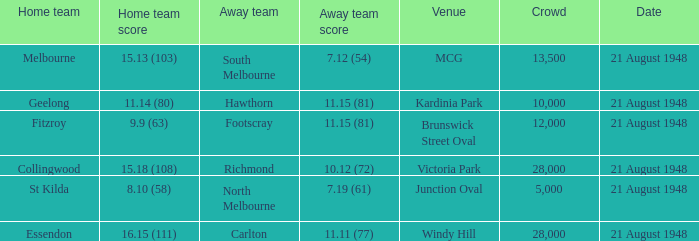At victoria park, what is the highest attendance recorded? 28000.0. 